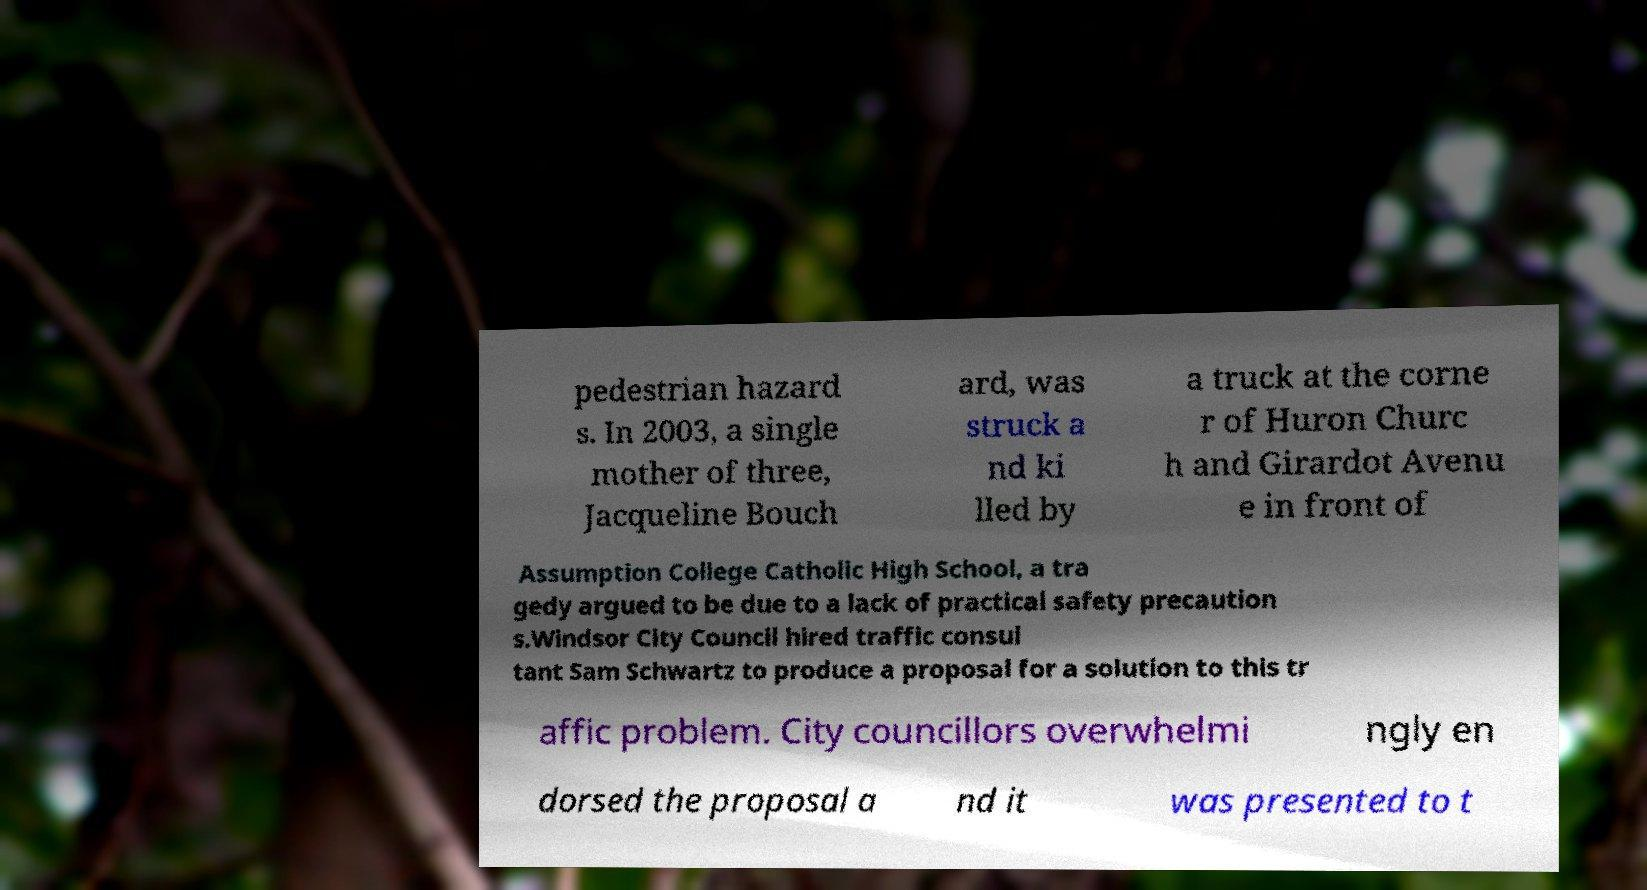Can you accurately transcribe the text from the provided image for me? pedestrian hazard s. In 2003, a single mother of three, Jacqueline Bouch ard, was struck a nd ki lled by a truck at the corne r of Huron Churc h and Girardot Avenu e in front of Assumption College Catholic High School, a tra gedy argued to be due to a lack of practical safety precaution s.Windsor City Council hired traffic consul tant Sam Schwartz to produce a proposal for a solution to this tr affic problem. City councillors overwhelmi ngly en dorsed the proposal a nd it was presented to t 